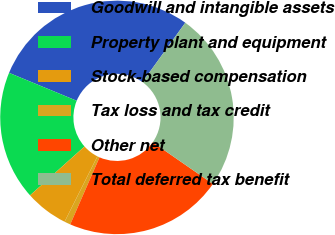<chart> <loc_0><loc_0><loc_500><loc_500><pie_chart><fcel>Goodwill and intangible assets<fcel>Property plant and equipment<fcel>Stock-based compensation<fcel>Tax loss and tax credit<fcel>Other net<fcel>Total deferred tax benefit<nl><fcel>28.72%<fcel>17.87%<fcel>5.96%<fcel>0.85%<fcel>21.91%<fcel>24.7%<nl></chart> 